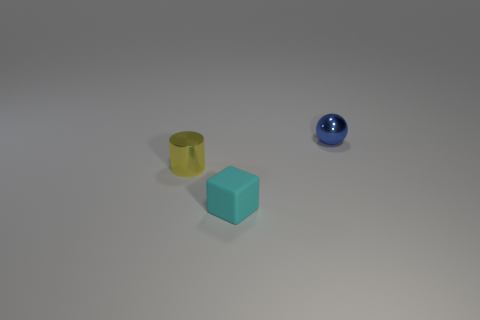How many objects are blue things or blue metal balls that are to the right of the small yellow shiny cylinder?
Make the answer very short. 1. There is a blue ball that is the same material as the small yellow object; what size is it?
Provide a short and direct response. Small. The small object to the left of the tiny thing in front of the tiny yellow shiny object is what shape?
Ensure brevity in your answer.  Cylinder. What number of cyan things are either large metallic things or cylinders?
Your answer should be compact. 0. There is a small thing behind the object that is left of the tiny cyan object; are there any small metal spheres that are behind it?
Your answer should be very brief. No. Is there anything else that has the same material as the tiny cyan object?
Keep it short and to the point. No. What number of small things are yellow cylinders or cyan rubber cubes?
Your answer should be very brief. 2. Do the metallic thing right of the small yellow cylinder and the yellow shiny object have the same shape?
Keep it short and to the point. No. Are there fewer large brown spheres than blue spheres?
Ensure brevity in your answer.  Yes. Is there anything else that has the same color as the tiny ball?
Ensure brevity in your answer.  No. 